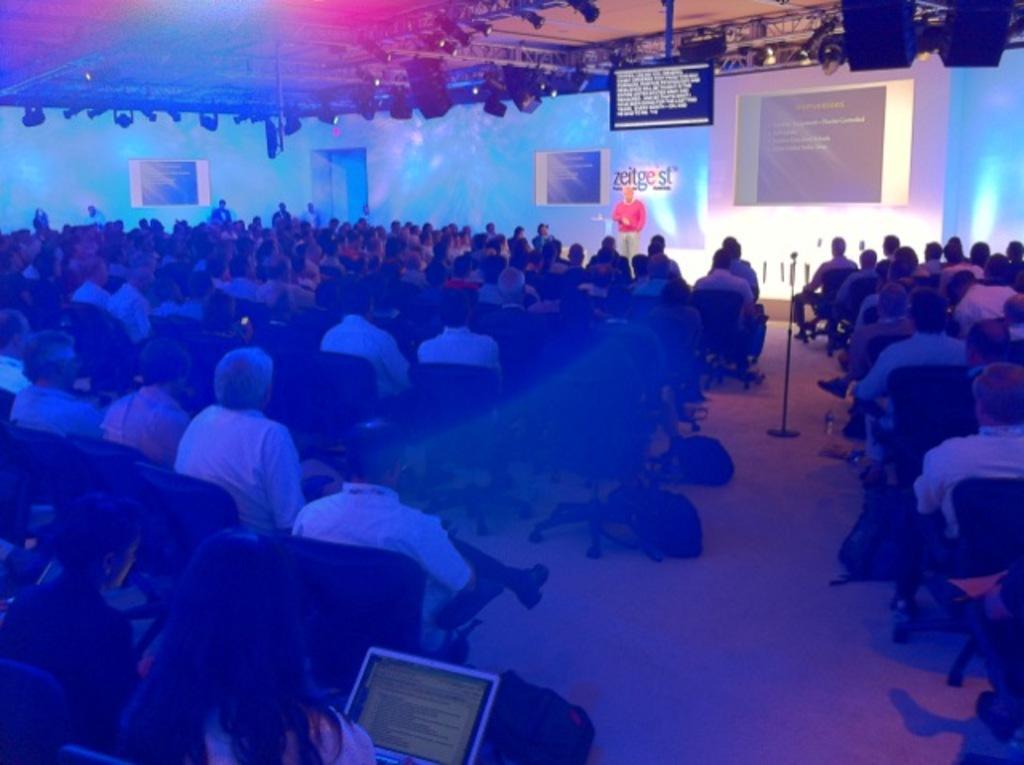In one or two sentences, can you explain what this image depicts? In this image in the middle, there is a man, he wears a red t shirt, trouser. In the middle there are many people, they are sitting. At the bottom there is a woman, she is holding a laptop, she's sitting. In the background there are some people, lights, posters, tv, screen, text. 